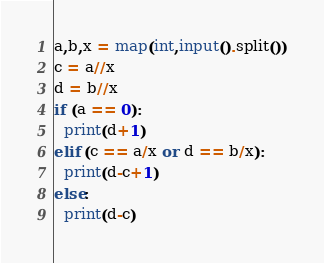Convert code to text. <code><loc_0><loc_0><loc_500><loc_500><_Python_>a,b,x = map(int,input().split())
c = a//x
d = b//x
if (a == 0):
  print(d+1)
elif (c == a/x or d == b/x):
  print(d-c+1)
else:
  print(d-c)</code> 